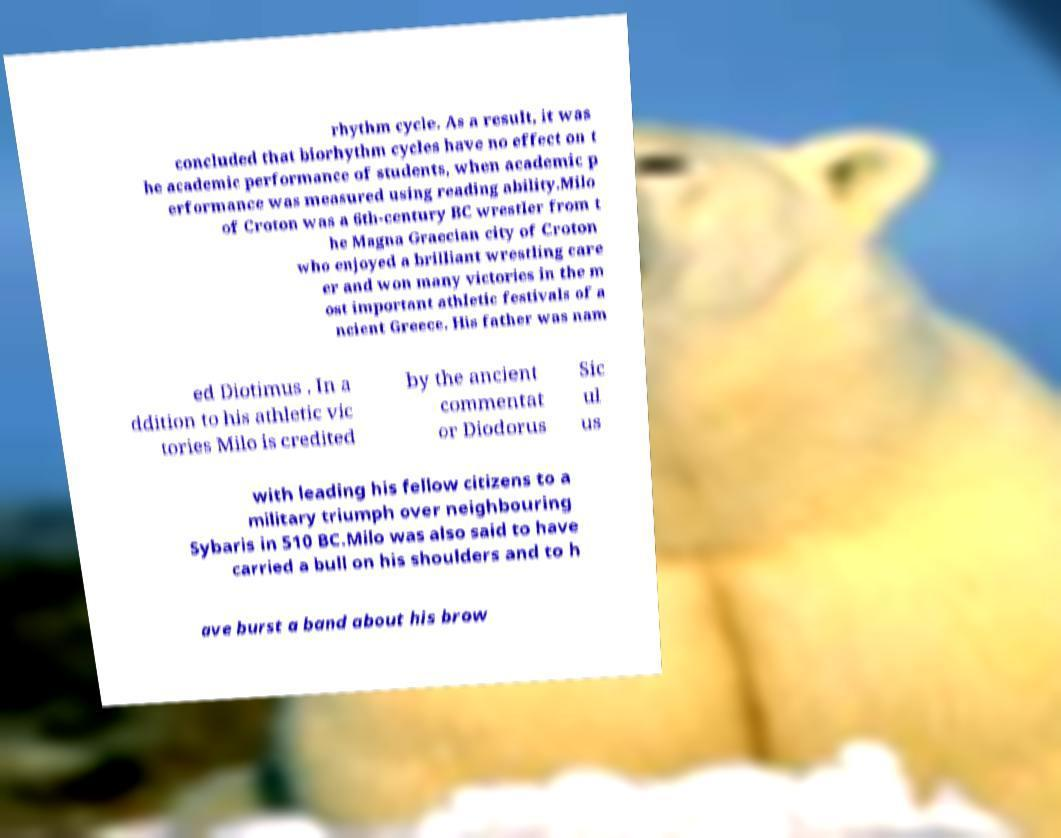What messages or text are displayed in this image? I need them in a readable, typed format. rhythm cycle. As a result, it was concluded that biorhythm cycles have no effect on t he academic performance of students, when academic p erformance was measured using reading ability.Milo of Croton was a 6th-century BC wrestler from t he Magna Graecian city of Croton who enjoyed a brilliant wrestling care er and won many victories in the m ost important athletic festivals of a ncient Greece. His father was nam ed Diotimus . In a ddition to his athletic vic tories Milo is credited by the ancient commentat or Diodorus Sic ul us with leading his fellow citizens to a military triumph over neighbouring Sybaris in 510 BC.Milo was also said to have carried a bull on his shoulders and to h ave burst a band about his brow 